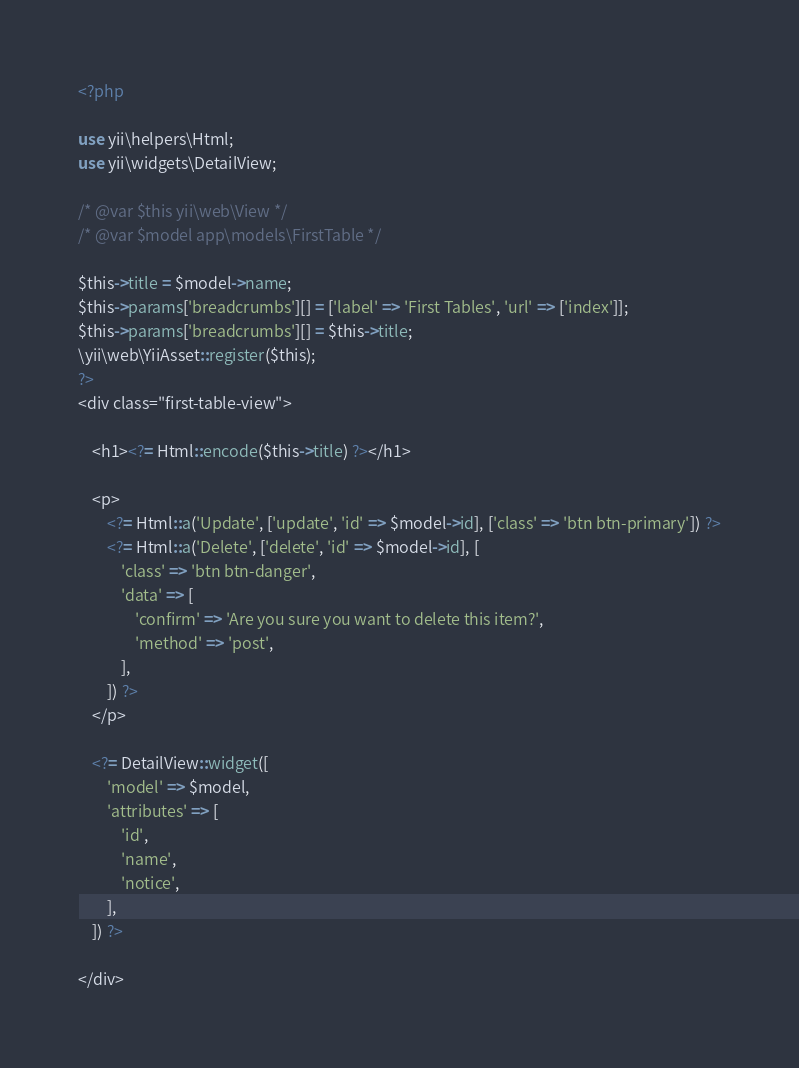Convert code to text. <code><loc_0><loc_0><loc_500><loc_500><_PHP_><?php

use yii\helpers\Html;
use yii\widgets\DetailView;

/* @var $this yii\web\View */
/* @var $model app\models\FirstTable */

$this->title = $model->name;
$this->params['breadcrumbs'][] = ['label' => 'First Tables', 'url' => ['index']];
$this->params['breadcrumbs'][] = $this->title;
\yii\web\YiiAsset::register($this);
?>
<div class="first-table-view">

    <h1><?= Html::encode($this->title) ?></h1>

    <p>
        <?= Html::a('Update', ['update', 'id' => $model->id], ['class' => 'btn btn-primary']) ?>
        <?= Html::a('Delete', ['delete', 'id' => $model->id], [
            'class' => 'btn btn-danger',
            'data' => [
                'confirm' => 'Are you sure you want to delete this item?',
                'method' => 'post',
            ],
        ]) ?>
    </p>

    <?= DetailView::widget([
        'model' => $model,
        'attributes' => [
            'id',
            'name',
            'notice',
        ],
    ]) ?>

</div>
</code> 